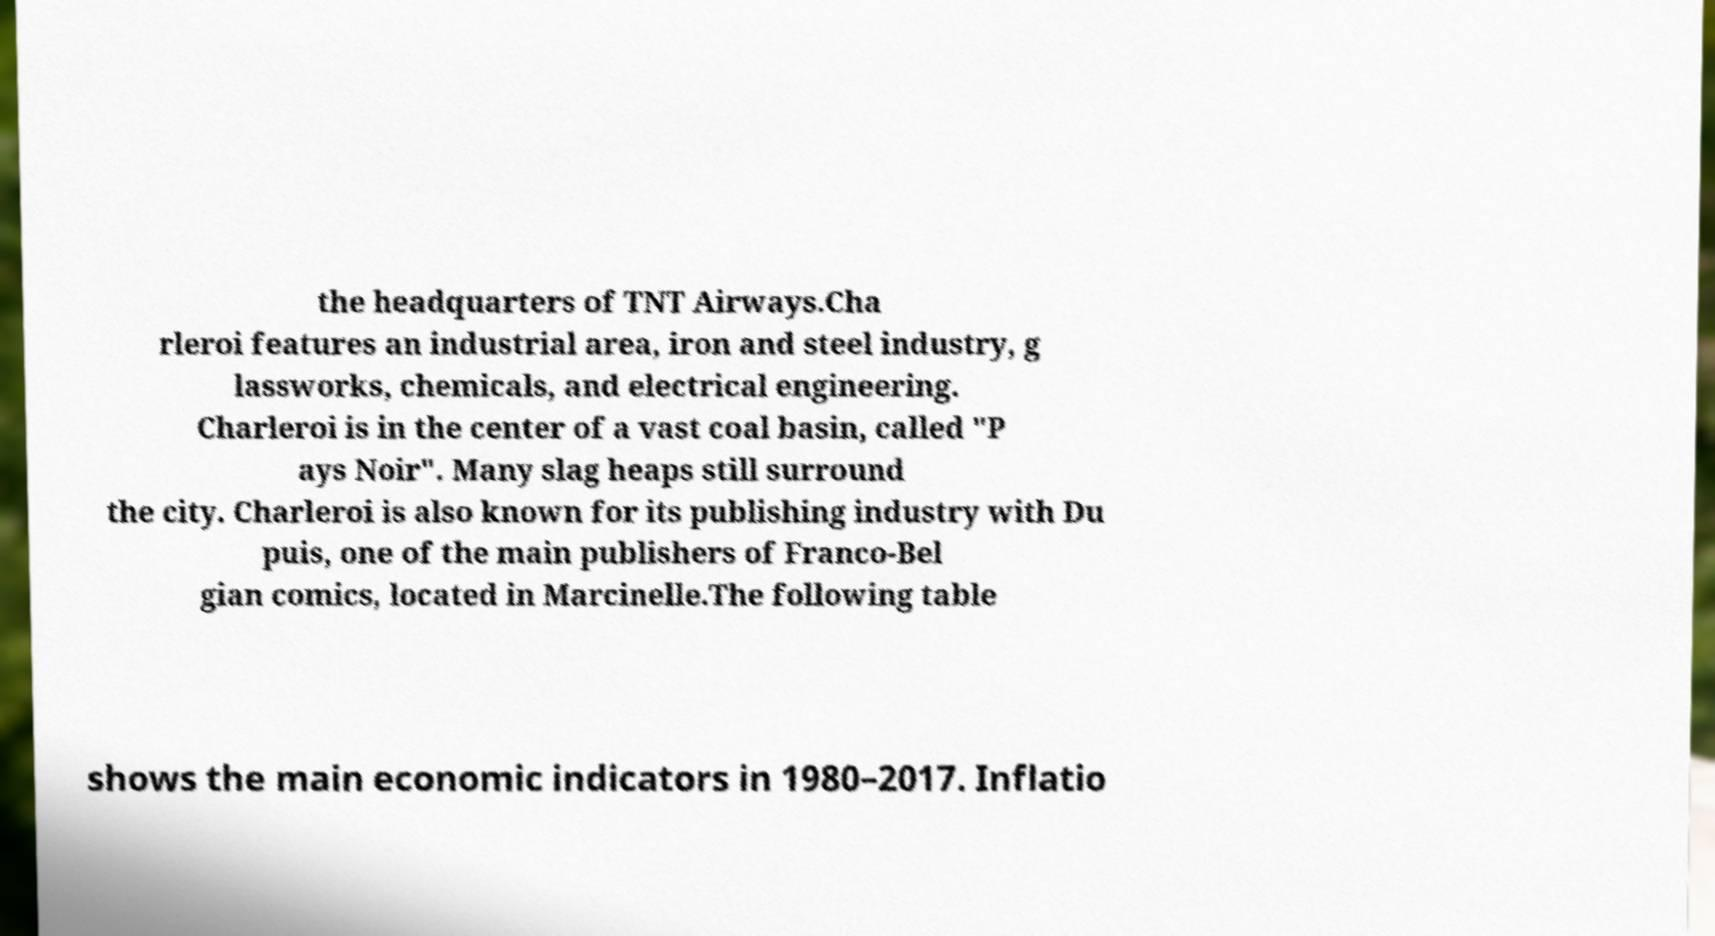What messages or text are displayed in this image? I need them in a readable, typed format. the headquarters of TNT Airways.Cha rleroi features an industrial area, iron and steel industry, g lassworks, chemicals, and electrical engineering. Charleroi is in the center of a vast coal basin, called "P ays Noir". Many slag heaps still surround the city. Charleroi is also known for its publishing industry with Du puis, one of the main publishers of Franco-Bel gian comics, located in Marcinelle.The following table shows the main economic indicators in 1980–2017. Inflatio 